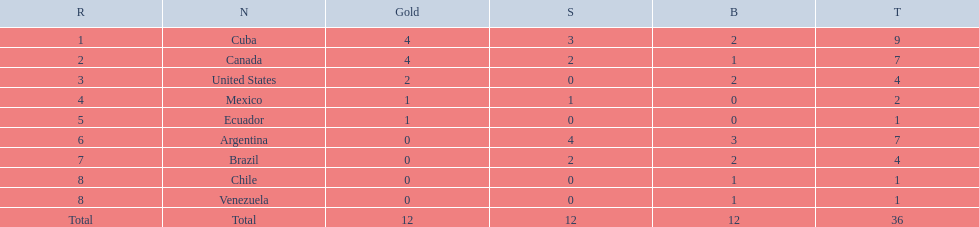Which countries won medals at the 2011 pan american games for the canoeing event? Cuba, Canada, United States, Mexico, Ecuador, Argentina, Brazil, Chile, Venezuela. Which of these countries won bronze medals? Cuba, Canada, United States, Argentina, Brazil, Chile, Venezuela. Of these countries, which won the most bronze medals? Argentina. 